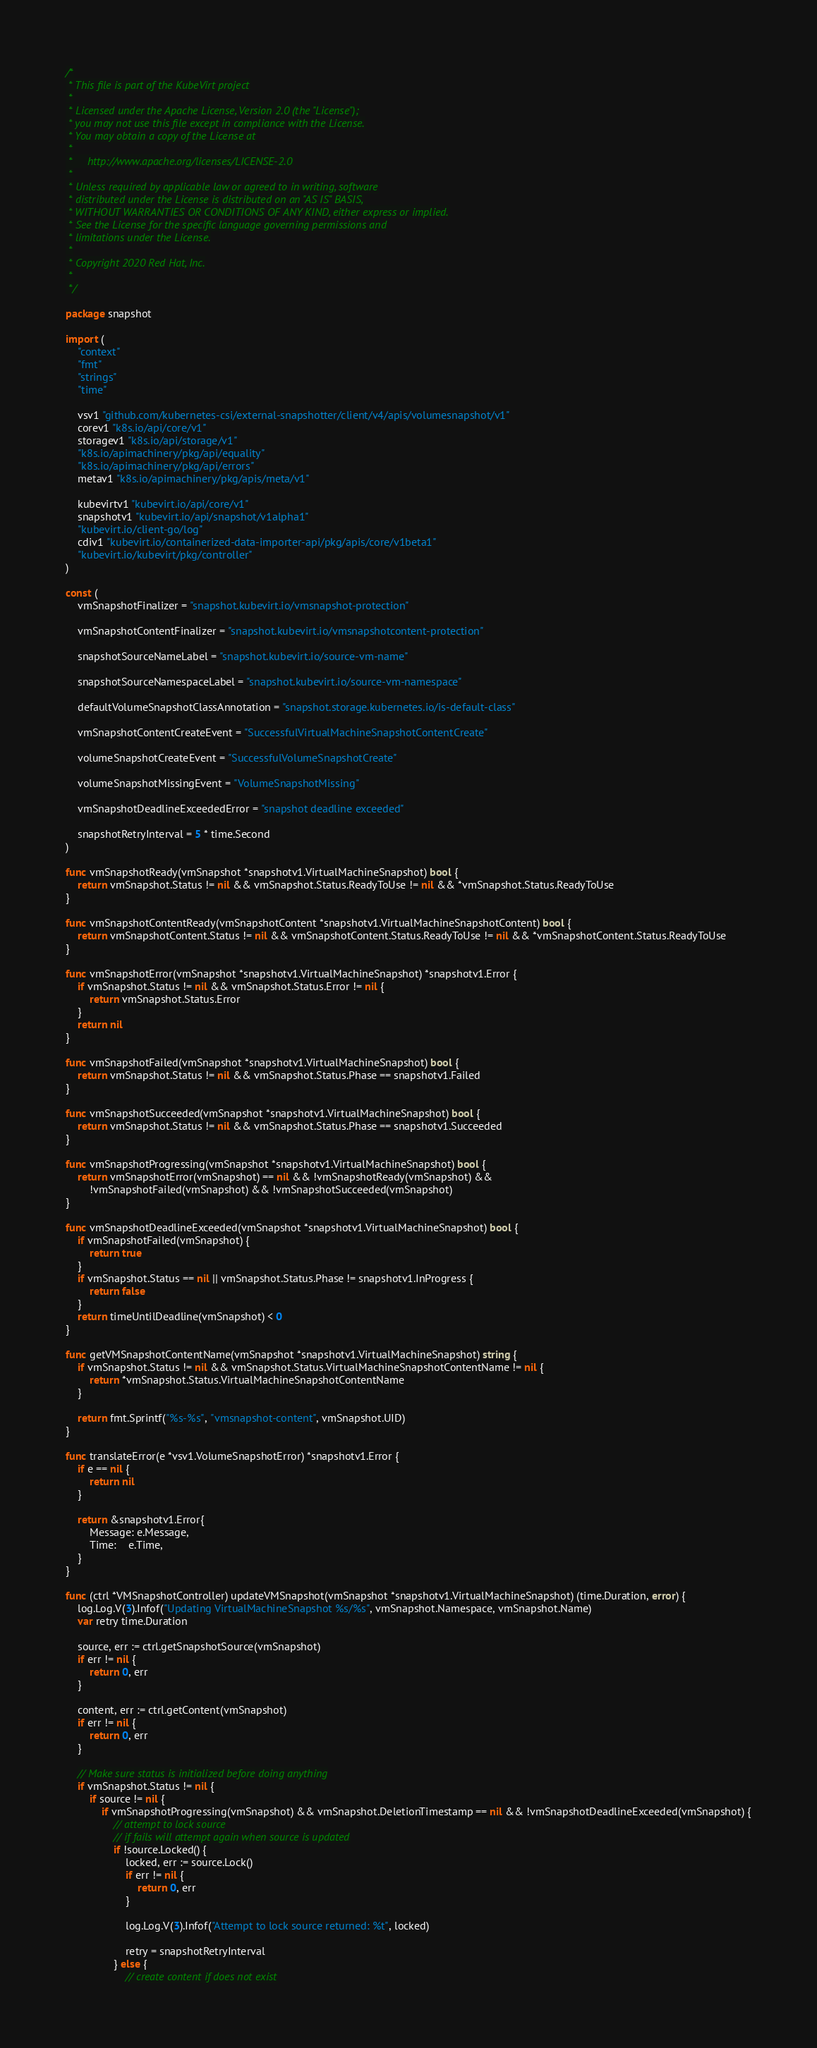<code> <loc_0><loc_0><loc_500><loc_500><_Go_>/*
 * This file is part of the KubeVirt project
 *
 * Licensed under the Apache License, Version 2.0 (the "License");
 * you may not use this file except in compliance with the License.
 * You may obtain a copy of the License at
 *
 *     http://www.apache.org/licenses/LICENSE-2.0
 *
 * Unless required by applicable law or agreed to in writing, software
 * distributed under the License is distributed on an "AS IS" BASIS,
 * WITHOUT WARRANTIES OR CONDITIONS OF ANY KIND, either express or implied.
 * See the License for the specific language governing permissions and
 * limitations under the License.
 *
 * Copyright 2020 Red Hat, Inc.
 *
 */

package snapshot

import (
	"context"
	"fmt"
	"strings"
	"time"

	vsv1 "github.com/kubernetes-csi/external-snapshotter/client/v4/apis/volumesnapshot/v1"
	corev1 "k8s.io/api/core/v1"
	storagev1 "k8s.io/api/storage/v1"
	"k8s.io/apimachinery/pkg/api/equality"
	"k8s.io/apimachinery/pkg/api/errors"
	metav1 "k8s.io/apimachinery/pkg/apis/meta/v1"

	kubevirtv1 "kubevirt.io/api/core/v1"
	snapshotv1 "kubevirt.io/api/snapshot/v1alpha1"
	"kubevirt.io/client-go/log"
	cdiv1 "kubevirt.io/containerized-data-importer-api/pkg/apis/core/v1beta1"
	"kubevirt.io/kubevirt/pkg/controller"
)

const (
	vmSnapshotFinalizer = "snapshot.kubevirt.io/vmsnapshot-protection"

	vmSnapshotContentFinalizer = "snapshot.kubevirt.io/vmsnapshotcontent-protection"

	snapshotSourceNameLabel = "snapshot.kubevirt.io/source-vm-name"

	snapshotSourceNamespaceLabel = "snapshot.kubevirt.io/source-vm-namespace"

	defaultVolumeSnapshotClassAnnotation = "snapshot.storage.kubernetes.io/is-default-class"

	vmSnapshotContentCreateEvent = "SuccessfulVirtualMachineSnapshotContentCreate"

	volumeSnapshotCreateEvent = "SuccessfulVolumeSnapshotCreate"

	volumeSnapshotMissingEvent = "VolumeSnapshotMissing"

	vmSnapshotDeadlineExceededError = "snapshot deadline exceeded"

	snapshotRetryInterval = 5 * time.Second
)

func vmSnapshotReady(vmSnapshot *snapshotv1.VirtualMachineSnapshot) bool {
	return vmSnapshot.Status != nil && vmSnapshot.Status.ReadyToUse != nil && *vmSnapshot.Status.ReadyToUse
}

func vmSnapshotContentReady(vmSnapshotContent *snapshotv1.VirtualMachineSnapshotContent) bool {
	return vmSnapshotContent.Status != nil && vmSnapshotContent.Status.ReadyToUse != nil && *vmSnapshotContent.Status.ReadyToUse
}

func vmSnapshotError(vmSnapshot *snapshotv1.VirtualMachineSnapshot) *snapshotv1.Error {
	if vmSnapshot.Status != nil && vmSnapshot.Status.Error != nil {
		return vmSnapshot.Status.Error
	}
	return nil
}

func vmSnapshotFailed(vmSnapshot *snapshotv1.VirtualMachineSnapshot) bool {
	return vmSnapshot.Status != nil && vmSnapshot.Status.Phase == snapshotv1.Failed
}

func vmSnapshotSucceeded(vmSnapshot *snapshotv1.VirtualMachineSnapshot) bool {
	return vmSnapshot.Status != nil && vmSnapshot.Status.Phase == snapshotv1.Succeeded
}

func vmSnapshotProgressing(vmSnapshot *snapshotv1.VirtualMachineSnapshot) bool {
	return vmSnapshotError(vmSnapshot) == nil && !vmSnapshotReady(vmSnapshot) &&
		!vmSnapshotFailed(vmSnapshot) && !vmSnapshotSucceeded(vmSnapshot)
}

func vmSnapshotDeadlineExceeded(vmSnapshot *snapshotv1.VirtualMachineSnapshot) bool {
	if vmSnapshotFailed(vmSnapshot) {
		return true
	}
	if vmSnapshot.Status == nil || vmSnapshot.Status.Phase != snapshotv1.InProgress {
		return false
	}
	return timeUntilDeadline(vmSnapshot) < 0
}

func getVMSnapshotContentName(vmSnapshot *snapshotv1.VirtualMachineSnapshot) string {
	if vmSnapshot.Status != nil && vmSnapshot.Status.VirtualMachineSnapshotContentName != nil {
		return *vmSnapshot.Status.VirtualMachineSnapshotContentName
	}

	return fmt.Sprintf("%s-%s", "vmsnapshot-content", vmSnapshot.UID)
}

func translateError(e *vsv1.VolumeSnapshotError) *snapshotv1.Error {
	if e == nil {
		return nil
	}

	return &snapshotv1.Error{
		Message: e.Message,
		Time:    e.Time,
	}
}

func (ctrl *VMSnapshotController) updateVMSnapshot(vmSnapshot *snapshotv1.VirtualMachineSnapshot) (time.Duration, error) {
	log.Log.V(3).Infof("Updating VirtualMachineSnapshot %s/%s", vmSnapshot.Namespace, vmSnapshot.Name)
	var retry time.Duration

	source, err := ctrl.getSnapshotSource(vmSnapshot)
	if err != nil {
		return 0, err
	}

	content, err := ctrl.getContent(vmSnapshot)
	if err != nil {
		return 0, err
	}

	// Make sure status is initialized before doing anything
	if vmSnapshot.Status != nil {
		if source != nil {
			if vmSnapshotProgressing(vmSnapshot) && vmSnapshot.DeletionTimestamp == nil && !vmSnapshotDeadlineExceeded(vmSnapshot) {
				// attempt to lock source
				// if fails will attempt again when source is updated
				if !source.Locked() {
					locked, err := source.Lock()
					if err != nil {
						return 0, err
					}

					log.Log.V(3).Infof("Attempt to lock source returned: %t", locked)

					retry = snapshotRetryInterval
				} else {
					// create content if does not exist</code> 